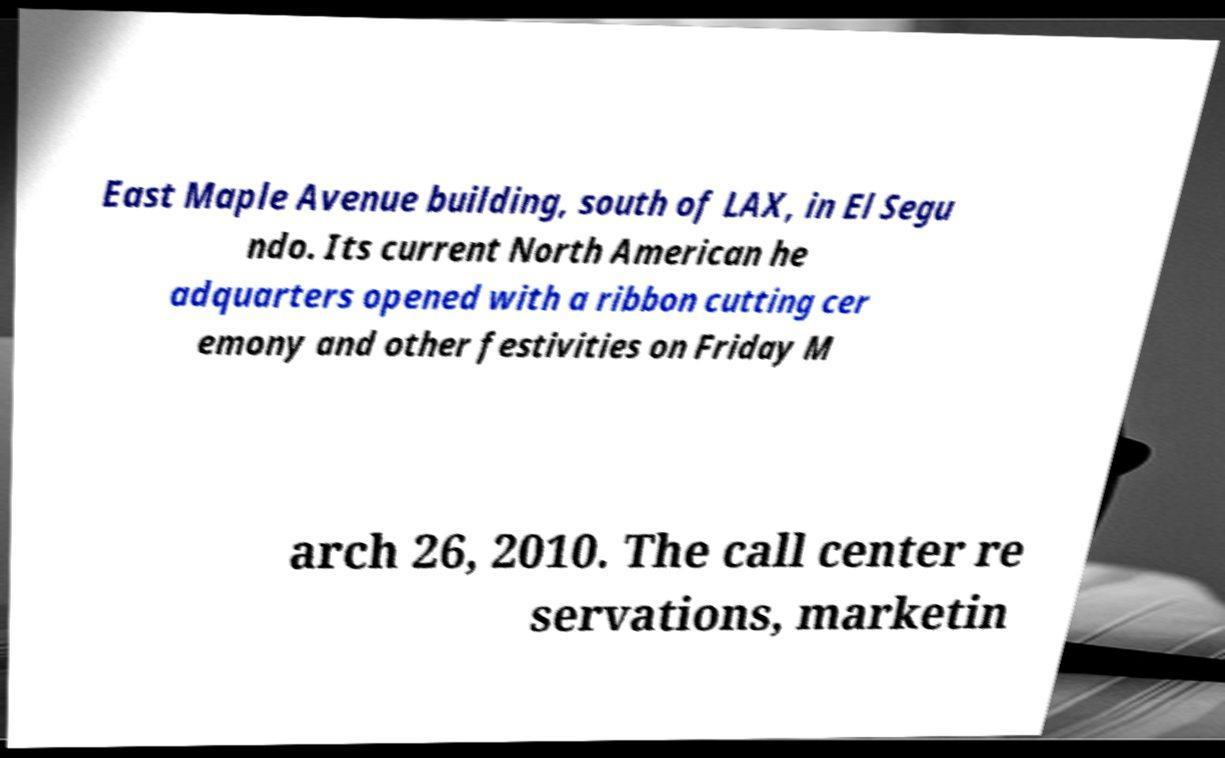For documentation purposes, I need the text within this image transcribed. Could you provide that? East Maple Avenue building, south of LAX, in El Segu ndo. Its current North American he adquarters opened with a ribbon cutting cer emony and other festivities on Friday M arch 26, 2010. The call center re servations, marketin 